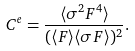Convert formula to latex. <formula><loc_0><loc_0><loc_500><loc_500>C ^ { e } = \frac { \langle \sigma ^ { 2 } F ^ { 4 } \rangle } { ( \langle { F } \rangle \langle \sigma { F } \rangle ) ^ { 2 } } .</formula> 